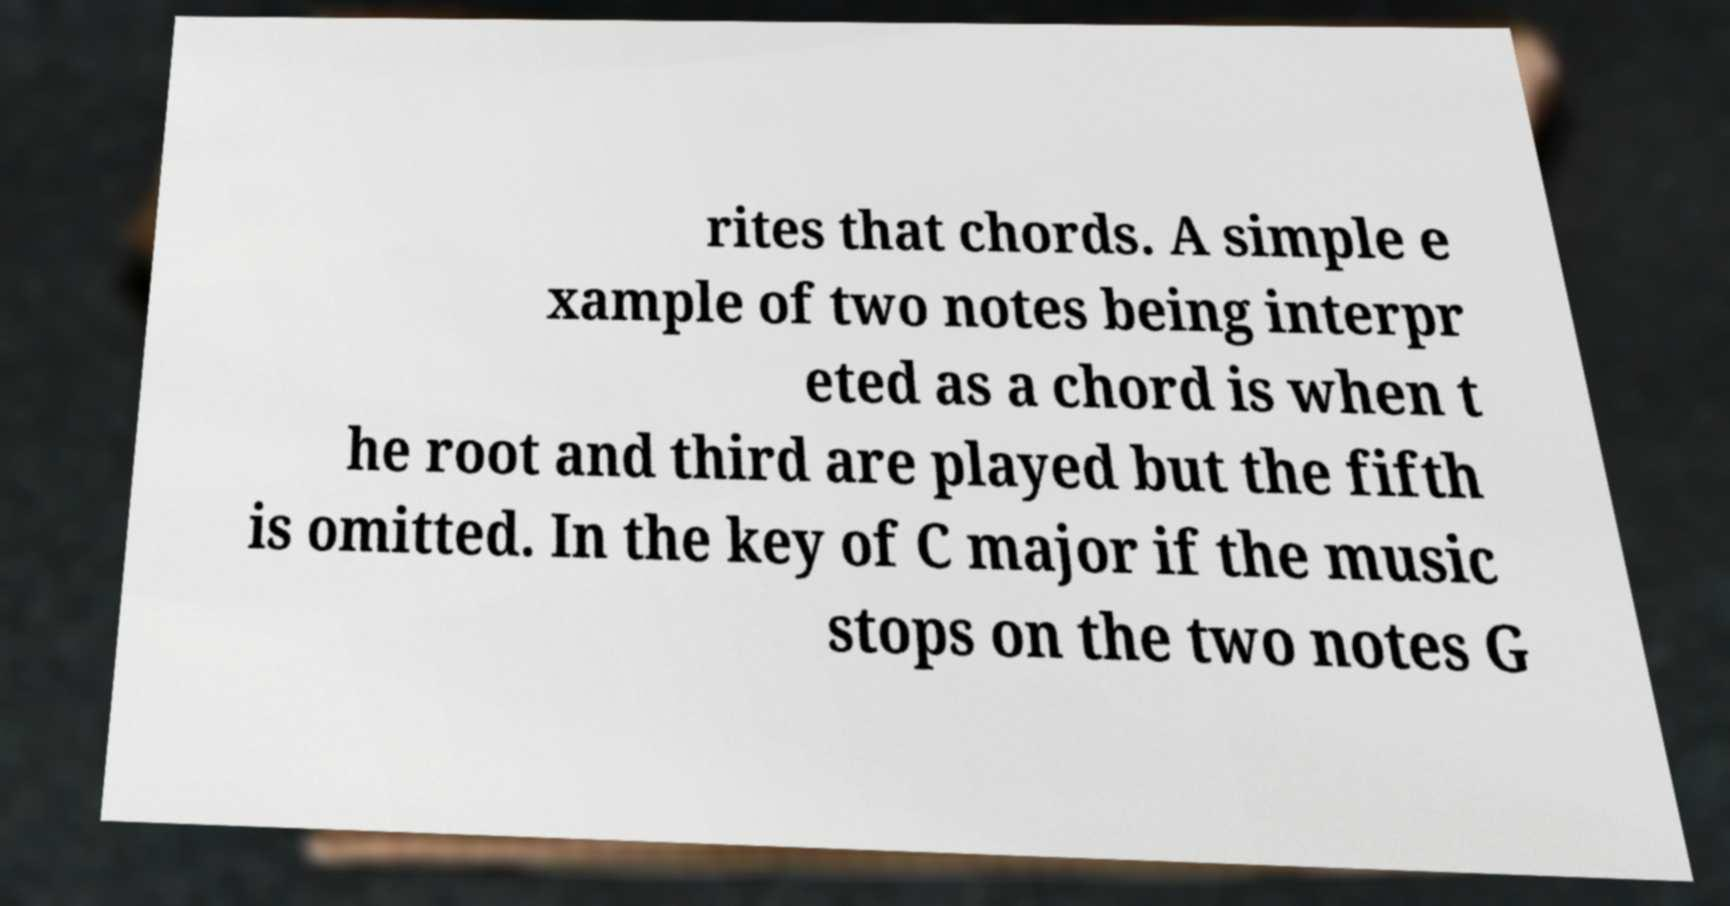I need the written content from this picture converted into text. Can you do that? rites that chords. A simple e xample of two notes being interpr eted as a chord is when t he root and third are played but the fifth is omitted. In the key of C major if the music stops on the two notes G 